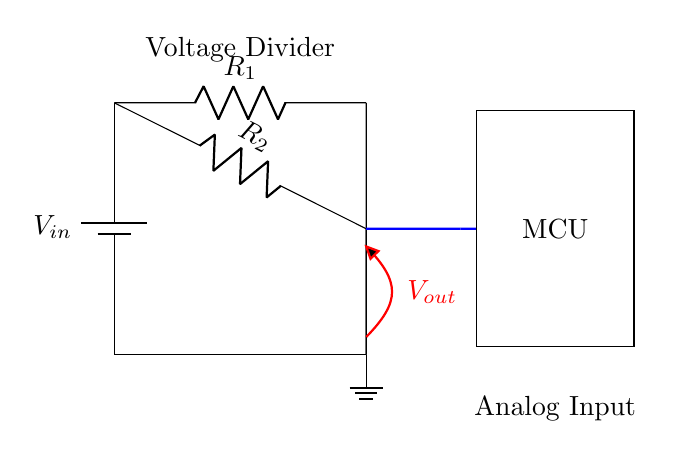What is the input voltage in this circuit? The input voltage is labeled as V_{in} and is sourced from a battery. The circuit schematic shows a battery symbol connected to the voltage divider, indicating the source of the input voltage.
Answer: V_{in} What are the values of the resistors used? The resistors are labeled as R_1 and R_2. The circuit does not specify their numerical values, but these labels indicate the resistors involved in the voltage divider.
Answer: R_1 and R_2 What is the purpose of the voltage divider? The voltage divider is used to reduce the voltage to a desired value that can be read by the microcontroller’s analog input. The configuration of the resistors allows for voltage division based on their values.
Answer: To reduce voltage What is the voltage output of the circuit? The output voltage is indicated as V_{out} and is taken from the junction of R_1 and R_2. This voltage is affected by the ratio of the resistors in the parallel configuration.
Answer: V_{out} Which component detects the output voltage? The microcontroller (MCU) is connected to the output voltage, receiving the voltage for processing. The diagram shows a connection between the output node and the MCU's analog input.
Answer: MCU How are the resistors configured in this circuit? The resistors R_1 and R_2 are connected in parallel, as shown in the circuit diagram where their terminals connect to the same points. In a voltage divider, this arrangement determines the voltage at the middle node due to the parallel current paths.
Answer: In parallel What does the thick red line represent in the circuit? The thick red line represents the output voltage V_{out}, connecting the intersection of the resistors R_1 and R_2 to the ground. It indicates where the output voltage is measured in relation to the other components.
Answer: V_{out} 